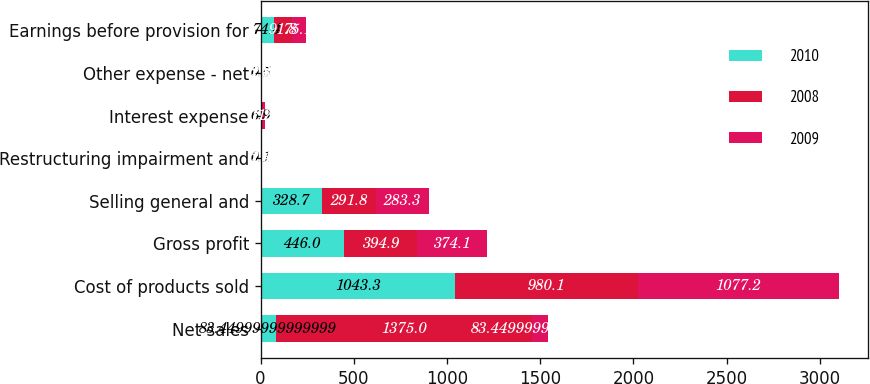Convert chart. <chart><loc_0><loc_0><loc_500><loc_500><stacked_bar_chart><ecel><fcel>Net sales<fcel>Cost of products sold<fcel>Gross profit<fcel>Selling general and<fcel>Restructuring impairment and<fcel>Interest expense<fcel>Other expense - net<fcel>Earnings before provision for<nl><fcel>2010<fcel>83.45<fcel>1043.3<fcel>446<fcel>328.7<fcel>0.1<fcel>6.9<fcel>0.5<fcel>74.4<nl><fcel>2008<fcel>1375<fcel>980.1<fcel>394.9<fcel>291.8<fcel>1.3<fcel>7.2<fcel>2.8<fcel>91.8<nl><fcel>2009<fcel>83.45<fcel>1077.2<fcel>374.1<fcel>283.3<fcel>2.4<fcel>11<fcel>2.3<fcel>75.1<nl></chart> 